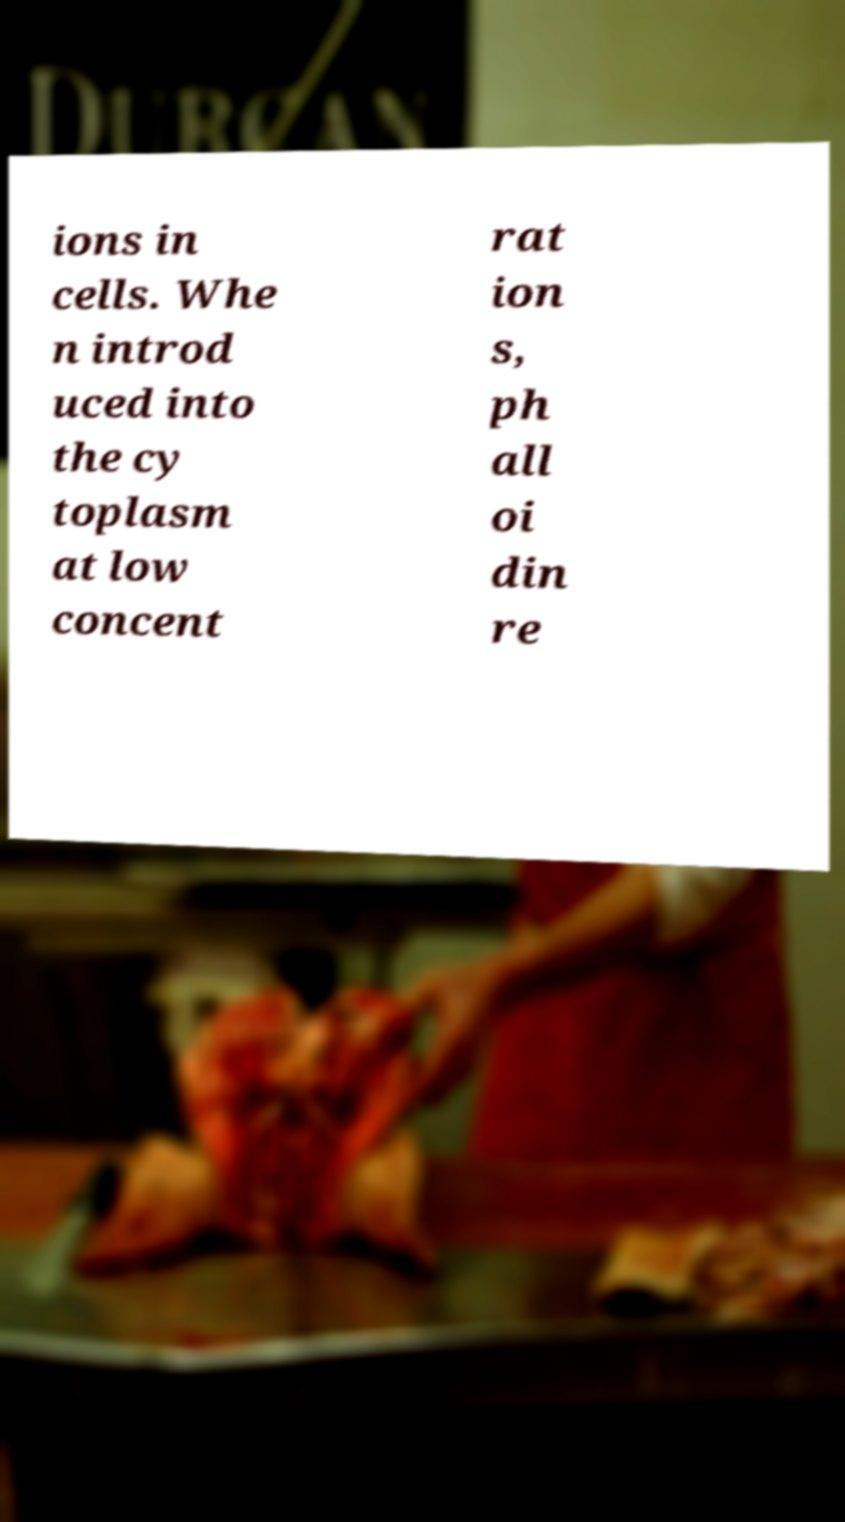I need the written content from this picture converted into text. Can you do that? ions in cells. Whe n introd uced into the cy toplasm at low concent rat ion s, ph all oi din re 